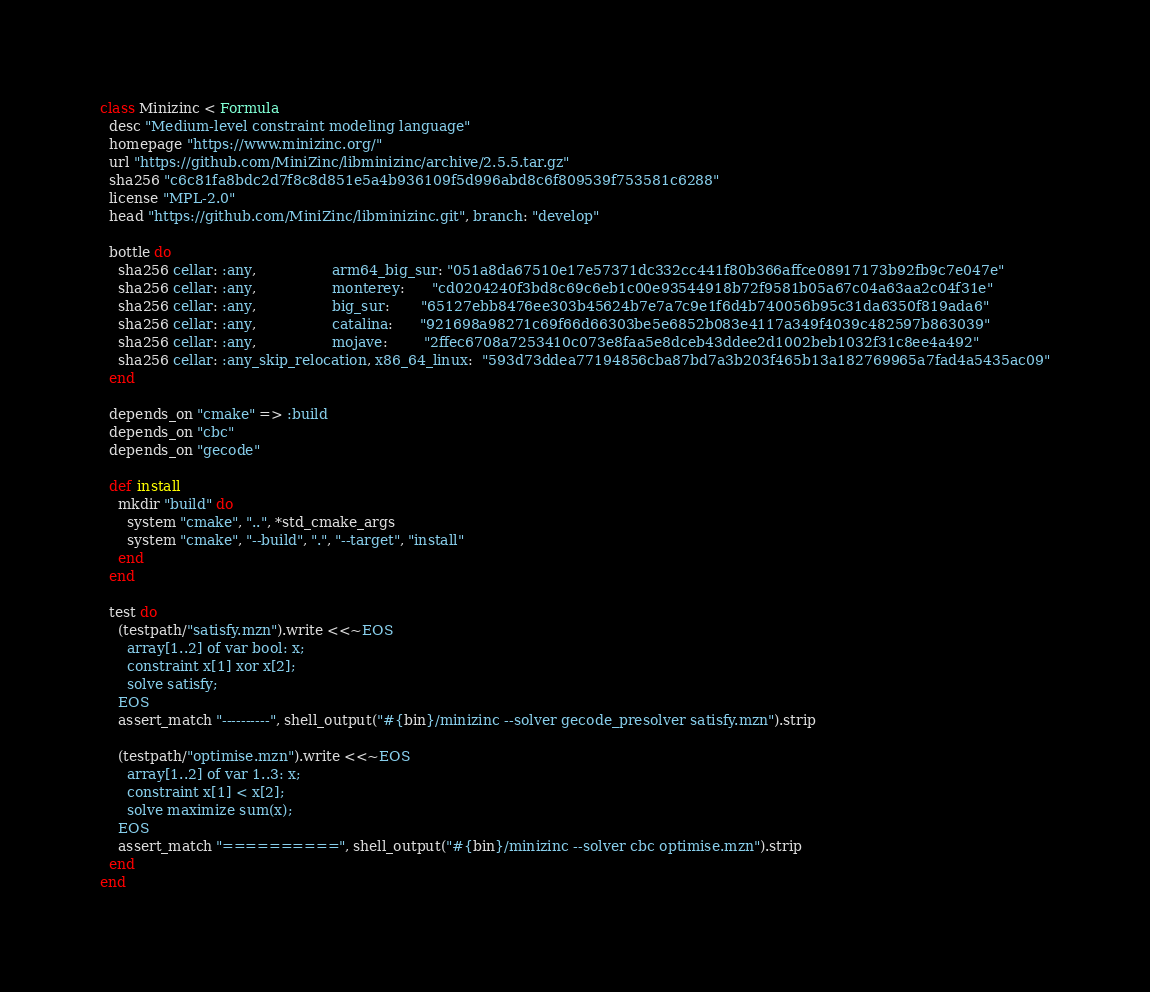<code> <loc_0><loc_0><loc_500><loc_500><_Ruby_>class Minizinc < Formula
  desc "Medium-level constraint modeling language"
  homepage "https://www.minizinc.org/"
  url "https://github.com/MiniZinc/libminizinc/archive/2.5.5.tar.gz"
  sha256 "c6c81fa8bdc2d7f8c8d851e5a4b936109f5d996abd8c6f809539f753581c6288"
  license "MPL-2.0"
  head "https://github.com/MiniZinc/libminizinc.git", branch: "develop"

  bottle do
    sha256 cellar: :any,                 arm64_big_sur: "051a8da67510e17e57371dc332cc441f80b366affce08917173b92fb9c7e047e"
    sha256 cellar: :any,                 monterey:      "cd0204240f3bd8c69c6eb1c00e93544918b72f9581b05a67c04a63aa2c04f31e"
    sha256 cellar: :any,                 big_sur:       "65127ebb8476ee303b45624b7e7a7c9e1f6d4b740056b95c31da6350f819ada6"
    sha256 cellar: :any,                 catalina:      "921698a98271c69f66d66303be5e6852b083e4117a349f4039c482597b863039"
    sha256 cellar: :any,                 mojave:        "2ffec6708a7253410c073e8faa5e8dceb43ddee2d1002beb1032f31c8ee4a492"
    sha256 cellar: :any_skip_relocation, x86_64_linux:  "593d73ddea77194856cba87bd7a3b203f465b13a182769965a7fad4a5435ac09"
  end

  depends_on "cmake" => :build
  depends_on "cbc"
  depends_on "gecode"

  def install
    mkdir "build" do
      system "cmake", "..", *std_cmake_args
      system "cmake", "--build", ".", "--target", "install"
    end
  end

  test do
    (testpath/"satisfy.mzn").write <<~EOS
      array[1..2] of var bool: x;
      constraint x[1] xor x[2];
      solve satisfy;
    EOS
    assert_match "----------", shell_output("#{bin}/minizinc --solver gecode_presolver satisfy.mzn").strip

    (testpath/"optimise.mzn").write <<~EOS
      array[1..2] of var 1..3: x;
      constraint x[1] < x[2];
      solve maximize sum(x);
    EOS
    assert_match "==========", shell_output("#{bin}/minizinc --solver cbc optimise.mzn").strip
  end
end
</code> 